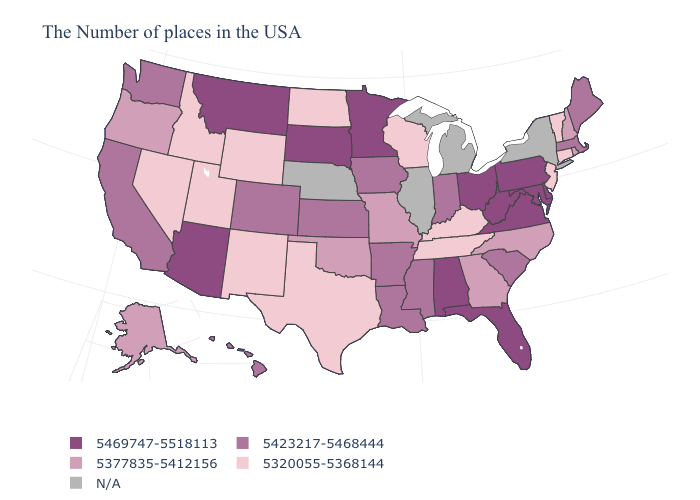Does Hawaii have the lowest value in the USA?
Keep it brief. No. Does the map have missing data?
Concise answer only. Yes. Does Colorado have the highest value in the West?
Be succinct. No. Does Kansas have the lowest value in the MidWest?
Concise answer only. No. What is the highest value in states that border Delaware?
Quick response, please. 5469747-5518113. Among the states that border Minnesota , which have the highest value?
Concise answer only. South Dakota. What is the value of Iowa?
Quick response, please. 5423217-5468444. What is the highest value in the USA?
Be succinct. 5469747-5518113. Does Alabama have the highest value in the South?
Give a very brief answer. Yes. Name the states that have a value in the range 5423217-5468444?
Answer briefly. Maine, Massachusetts, South Carolina, Indiana, Mississippi, Louisiana, Arkansas, Iowa, Kansas, Colorado, California, Washington, Hawaii. What is the value of Kansas?
Keep it brief. 5423217-5468444. Name the states that have a value in the range N/A?
Concise answer only. New York, Michigan, Illinois, Nebraska. Does Wyoming have the lowest value in the USA?
Concise answer only. Yes. What is the value of Michigan?
Short answer required. N/A. Which states have the highest value in the USA?
Quick response, please. Delaware, Maryland, Pennsylvania, Virginia, West Virginia, Ohio, Florida, Alabama, Minnesota, South Dakota, Montana, Arizona. 